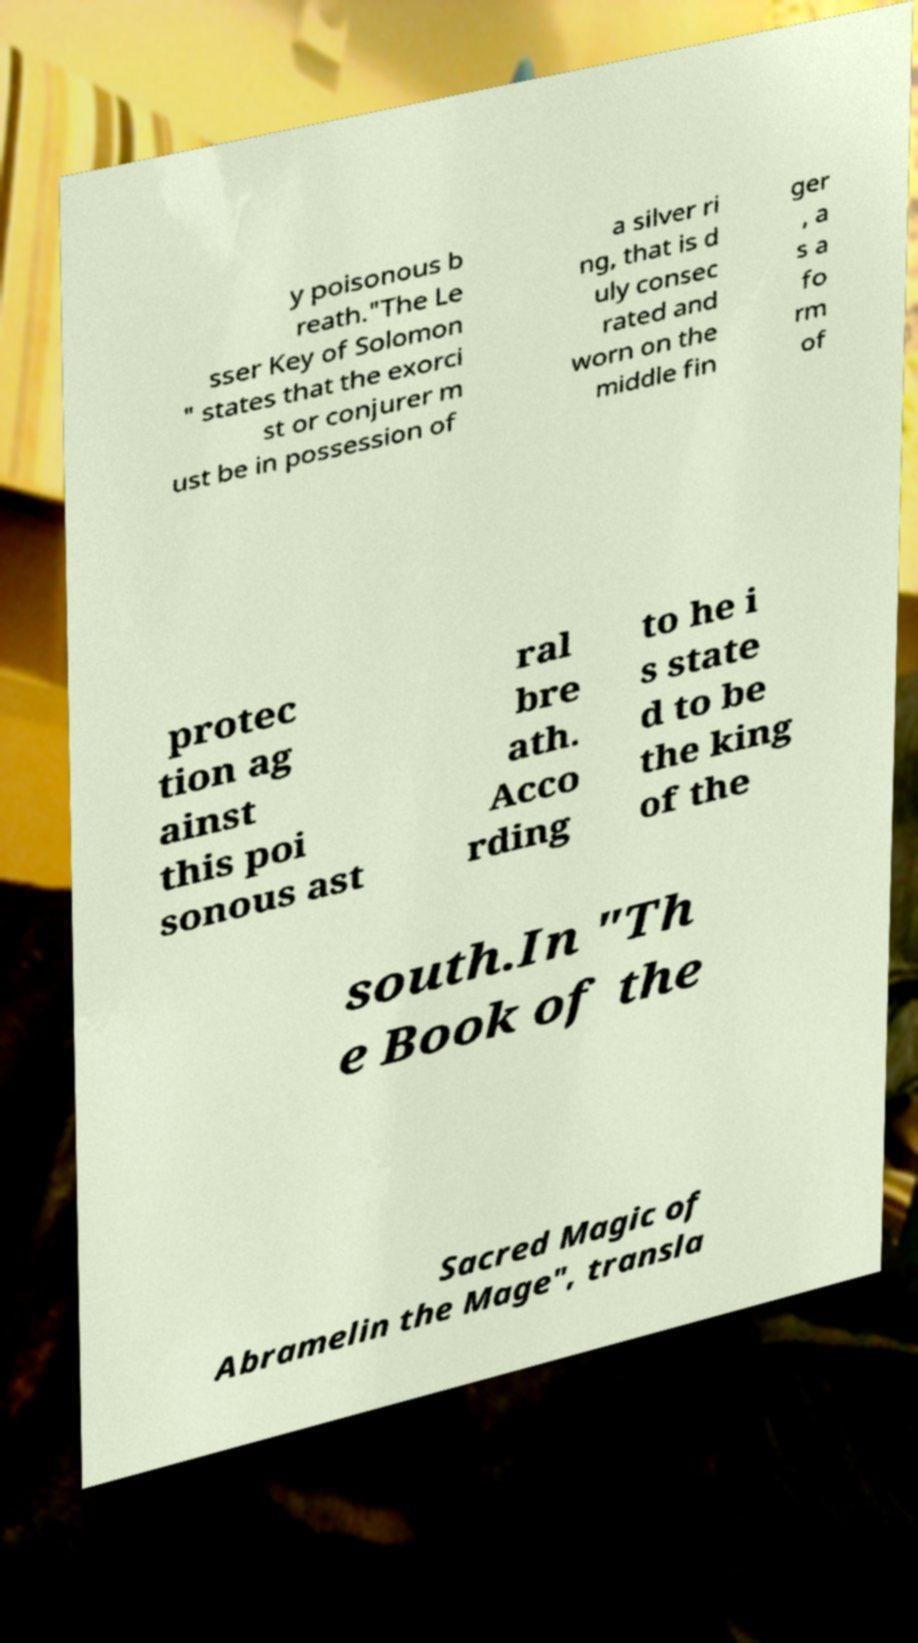Please identify and transcribe the text found in this image. y poisonous b reath."The Le sser Key of Solomon " states that the exorci st or conjurer m ust be in possession of a silver ri ng, that is d uly consec rated and worn on the middle fin ger , a s a fo rm of protec tion ag ainst this poi sonous ast ral bre ath. Acco rding to he i s state d to be the king of the south.In "Th e Book of the Sacred Magic of Abramelin the Mage", transla 